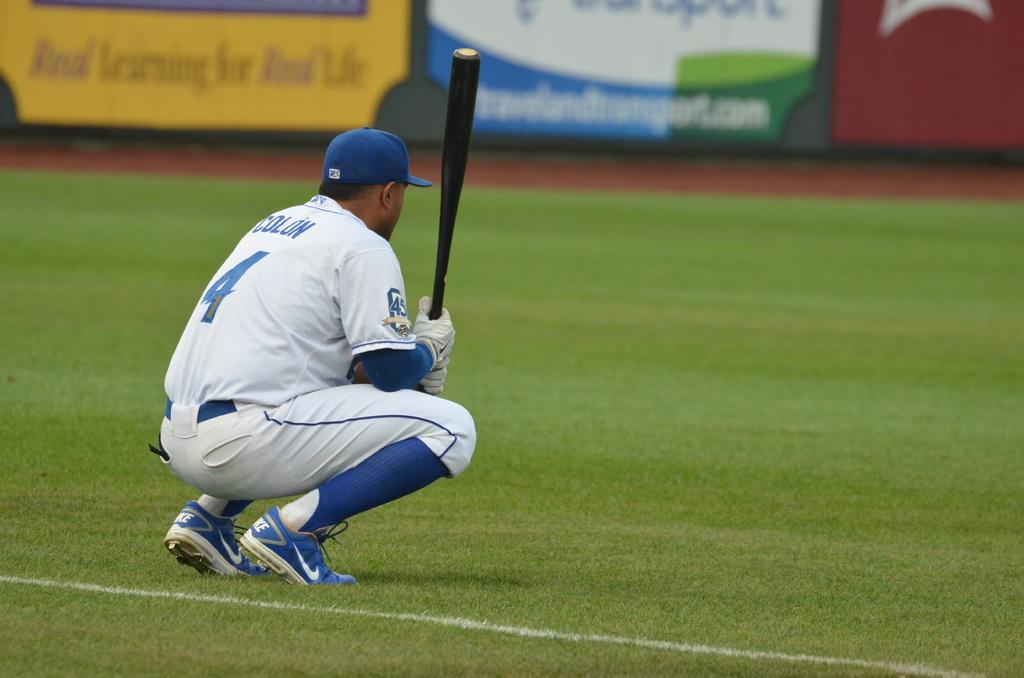<image>
Describe the image concisely. A baseball player wears the number four on his jersey. 